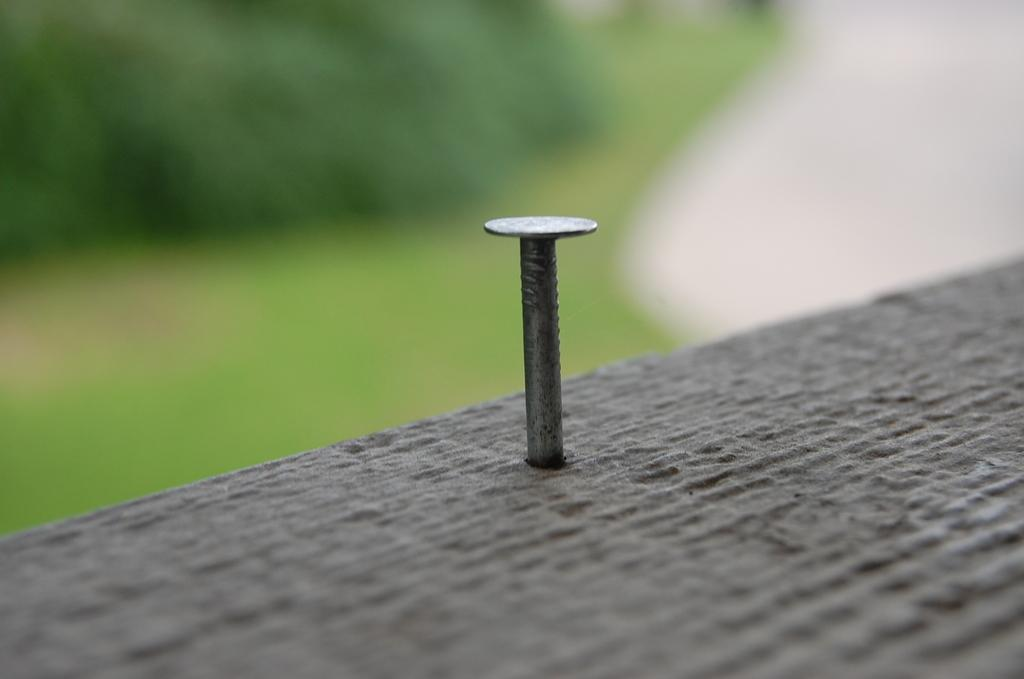What is the main subject of the image? There is an object in the image. Can you describe any specific features of the object? The object has a screw inserted in it. What can be observed about the background of the image? The background of the image is blurry. How does the object express disgust in the image? The object does not express any emotions, including disgust, as it is an inanimate object. 